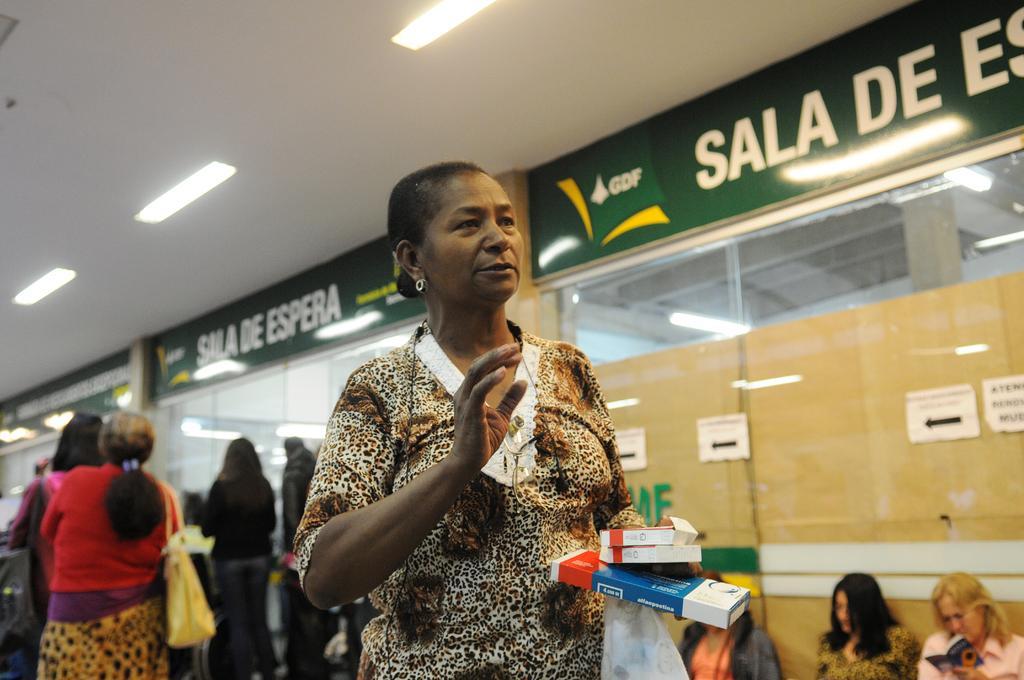Can you describe this image briefly? In this picture there are people, among them there is a woman holding boxes and cover. In the background of the image we can see boards and posters on glass. At the top of the image we can see lights. 